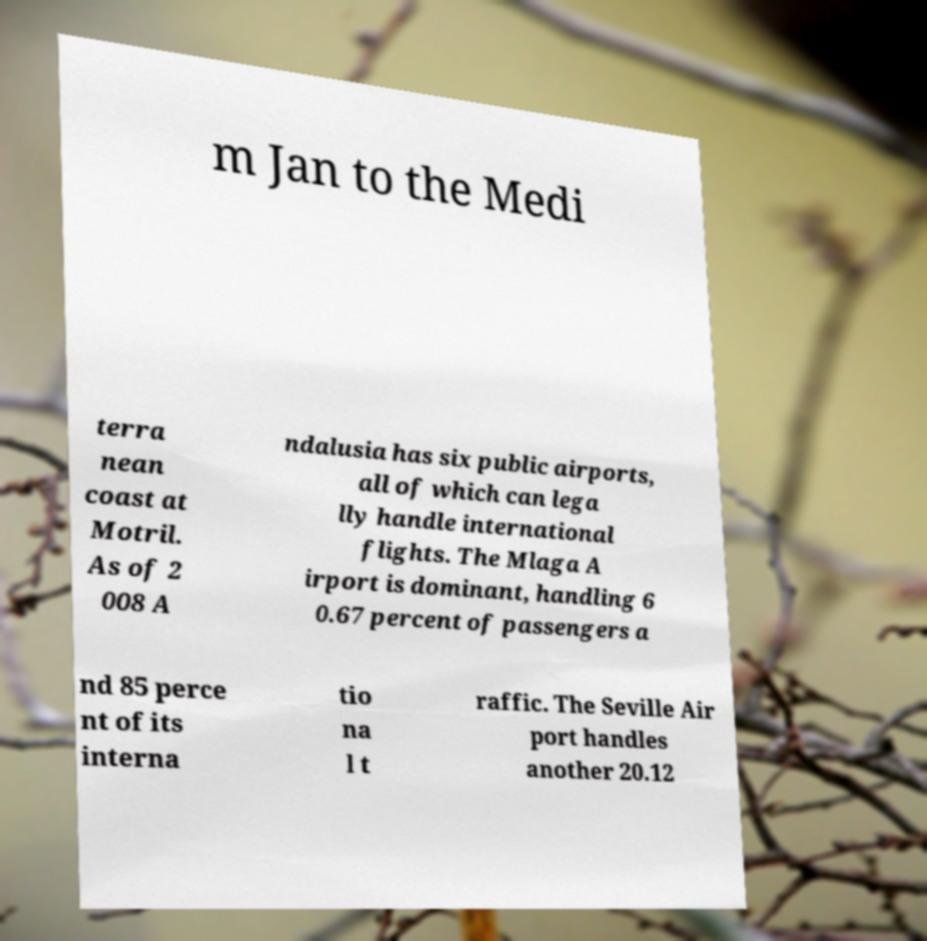Can you read and provide the text displayed in the image?This photo seems to have some interesting text. Can you extract and type it out for me? m Jan to the Medi terra nean coast at Motril. As of 2 008 A ndalusia has six public airports, all of which can lega lly handle international flights. The Mlaga A irport is dominant, handling 6 0.67 percent of passengers a nd 85 perce nt of its interna tio na l t raffic. The Seville Air port handles another 20.12 